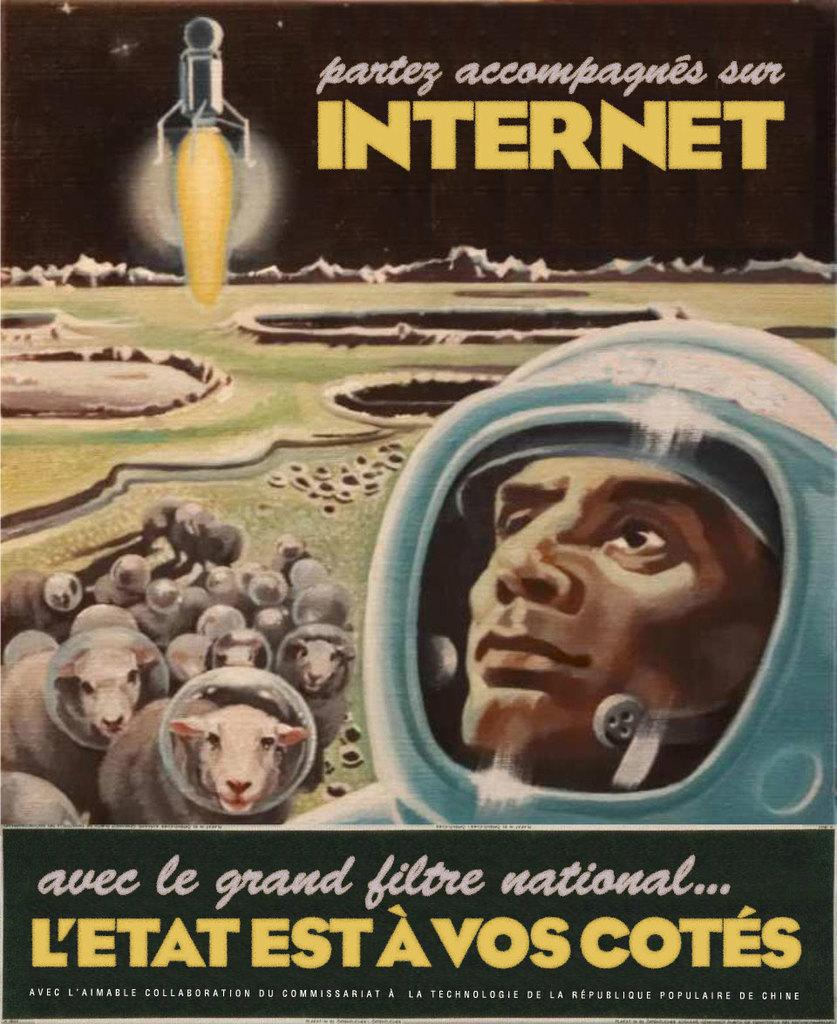<image>
Describe the image concisely. A picture of a man and some sheep in space with the word Internet visible. 